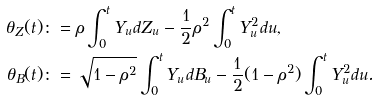Convert formula to latex. <formula><loc_0><loc_0><loc_500><loc_500>\theta _ { Z } ( t ) & \colon = \rho \int _ { 0 } ^ { t } Y _ { u } d Z _ { u } - \frac { 1 } { 2 } \rho ^ { 2 } \int _ { 0 } ^ { t } Y _ { u } ^ { 2 } d u , \\ \theta _ { B } ( t ) & \colon = \sqrt { 1 - \rho ^ { 2 } } \int _ { 0 } ^ { t } Y _ { u } d B _ { u } - \frac { 1 } { 2 } ( 1 - \rho ^ { 2 } ) \int _ { 0 } ^ { t } Y _ { u } ^ { 2 } d u .</formula> 